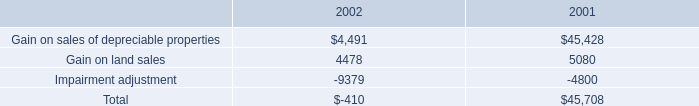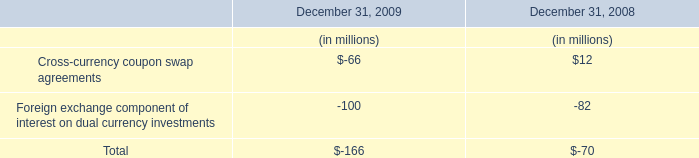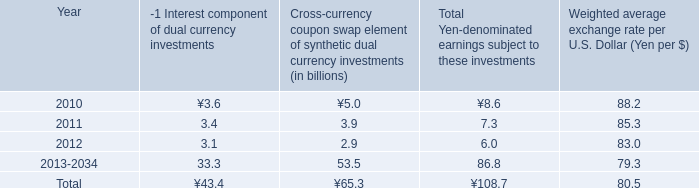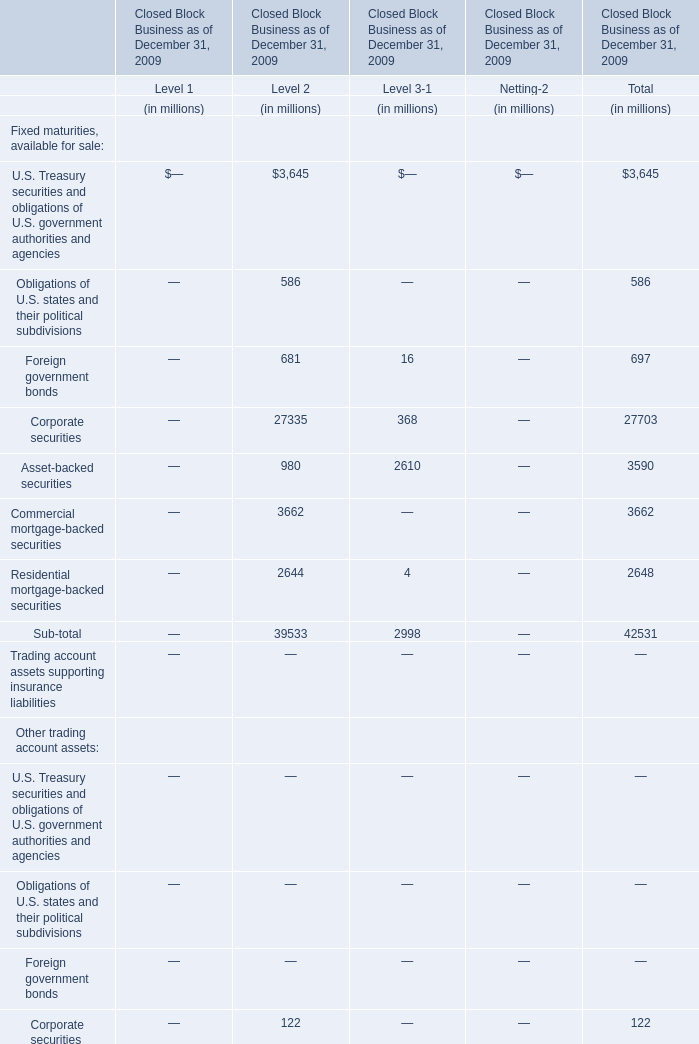what was the percentage change in the general and administrative expenses from 2001 to , 2002 . 
Computations: ((25.4 - 15.6) / 15.6)
Answer: 0.62821. 